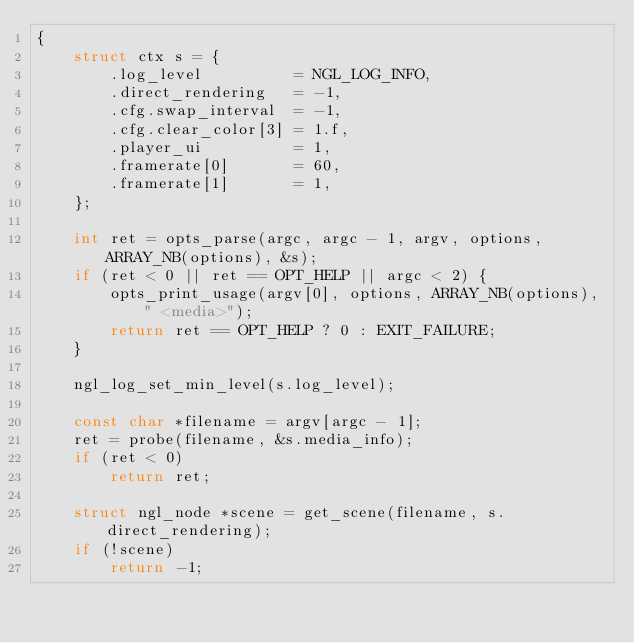Convert code to text. <code><loc_0><loc_0><loc_500><loc_500><_C_>{
    struct ctx s = {
        .log_level          = NGL_LOG_INFO,
        .direct_rendering   = -1,
        .cfg.swap_interval  = -1,
        .cfg.clear_color[3] = 1.f,
        .player_ui          = 1,
        .framerate[0]       = 60,
        .framerate[1]       = 1,
    };

    int ret = opts_parse(argc, argc - 1, argv, options, ARRAY_NB(options), &s);
    if (ret < 0 || ret == OPT_HELP || argc < 2) {
        opts_print_usage(argv[0], options, ARRAY_NB(options), " <media>");
        return ret == OPT_HELP ? 0 : EXIT_FAILURE;
    }

    ngl_log_set_min_level(s.log_level);

    const char *filename = argv[argc - 1];
    ret = probe(filename, &s.media_info);
    if (ret < 0)
        return ret;

    struct ngl_node *scene = get_scene(filename, s.direct_rendering);
    if (!scene)
        return -1;
</code> 